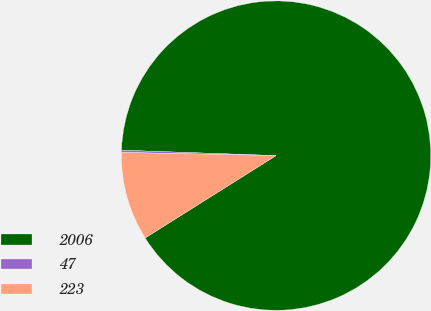Convert chart to OTSL. <chart><loc_0><loc_0><loc_500><loc_500><pie_chart><fcel>2006<fcel>47<fcel>223<nl><fcel>90.5%<fcel>0.23%<fcel>9.26%<nl></chart> 